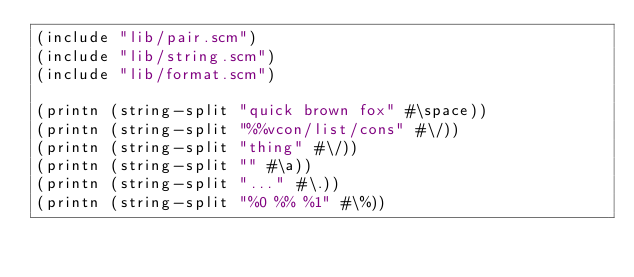<code> <loc_0><loc_0><loc_500><loc_500><_Scheme_>(include "lib/pair.scm")
(include "lib/string.scm")
(include "lib/format.scm")

(printn (string-split "quick brown fox" #\space))
(printn (string-split "%%vcon/list/cons" #\/))
(printn (string-split "thing" #\/))
(printn (string-split "" #\a))
(printn (string-split "..." #\.))
(printn (string-split "%0 %% %1" #\%))

</code> 